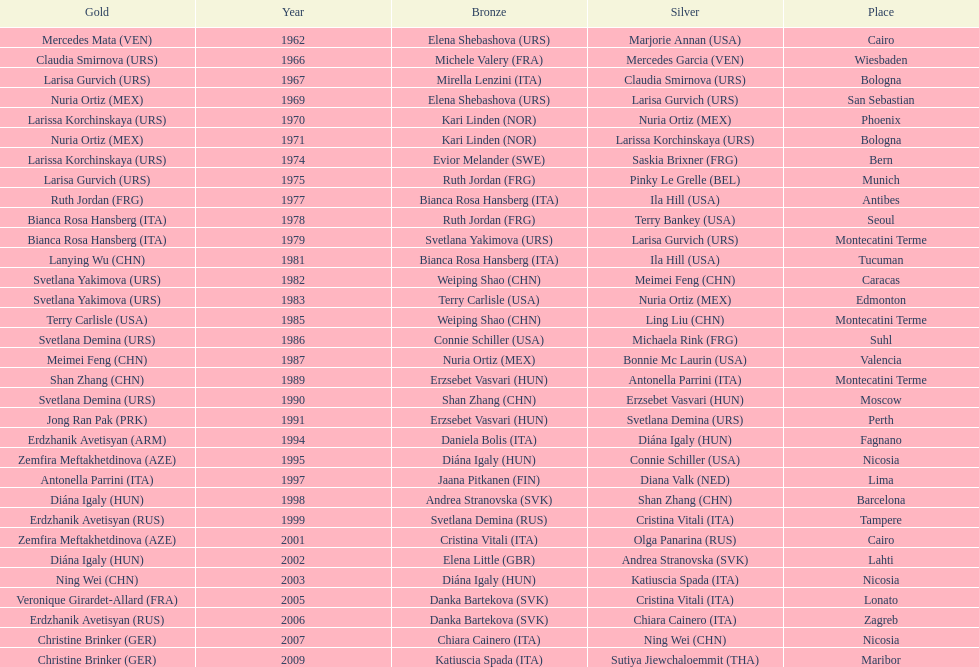What is the overall amount of silver in cairo? 0. 